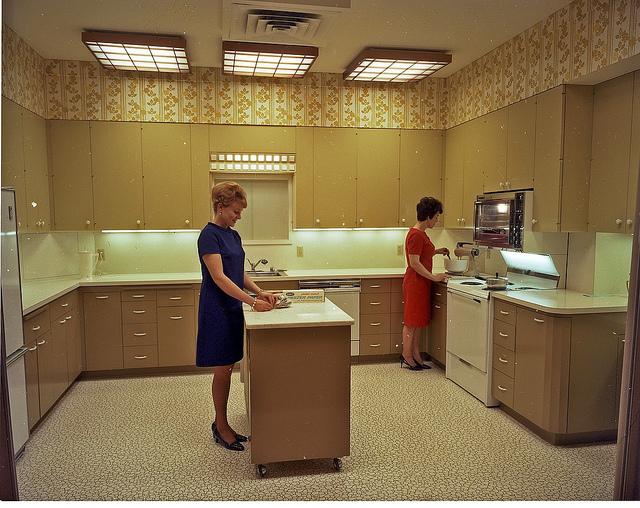How many women are in this picture?
Quick response, please. 2. What era does this appear to be?
Be succinct. 1950s. What room is this?
Be succinct. Kitchen. 